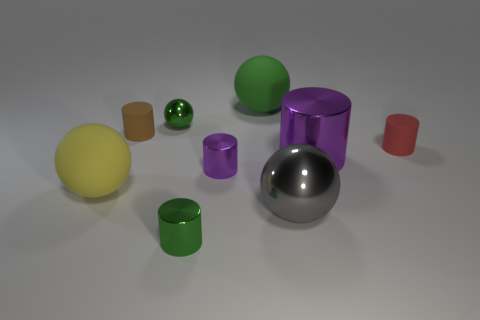There is a big matte object that is behind the tiny red cylinder; is its color the same as the metal ball that is behind the small purple cylinder?
Ensure brevity in your answer.  Yes. Do the purple cylinder to the right of the gray ball and the cylinder that is in front of the large metallic sphere have the same material?
Ensure brevity in your answer.  Yes. What number of large objects are on the right side of the green shiny thing that is in front of the large yellow matte thing?
Offer a very short reply. 3. Is the shape of the tiny green metallic thing in front of the red cylinder the same as the tiny thing that is right of the big purple metallic cylinder?
Provide a succinct answer. Yes. There is a cylinder that is both on the left side of the tiny purple object and in front of the tiny red rubber thing; what is its size?
Your answer should be compact. Small. There is a large shiny thing that is the same shape as the tiny purple object; what is its color?
Your response must be concise. Purple. What is the color of the shiny object behind the rubber cylinder that is left of the large green thing?
Give a very brief answer. Green. What shape is the green rubber object?
Offer a terse response. Sphere. What shape is the green object that is on the left side of the big green matte object and on the right side of the small metal sphere?
Make the answer very short. Cylinder. There is a small sphere that is the same material as the tiny green cylinder; what is its color?
Your response must be concise. Green. 